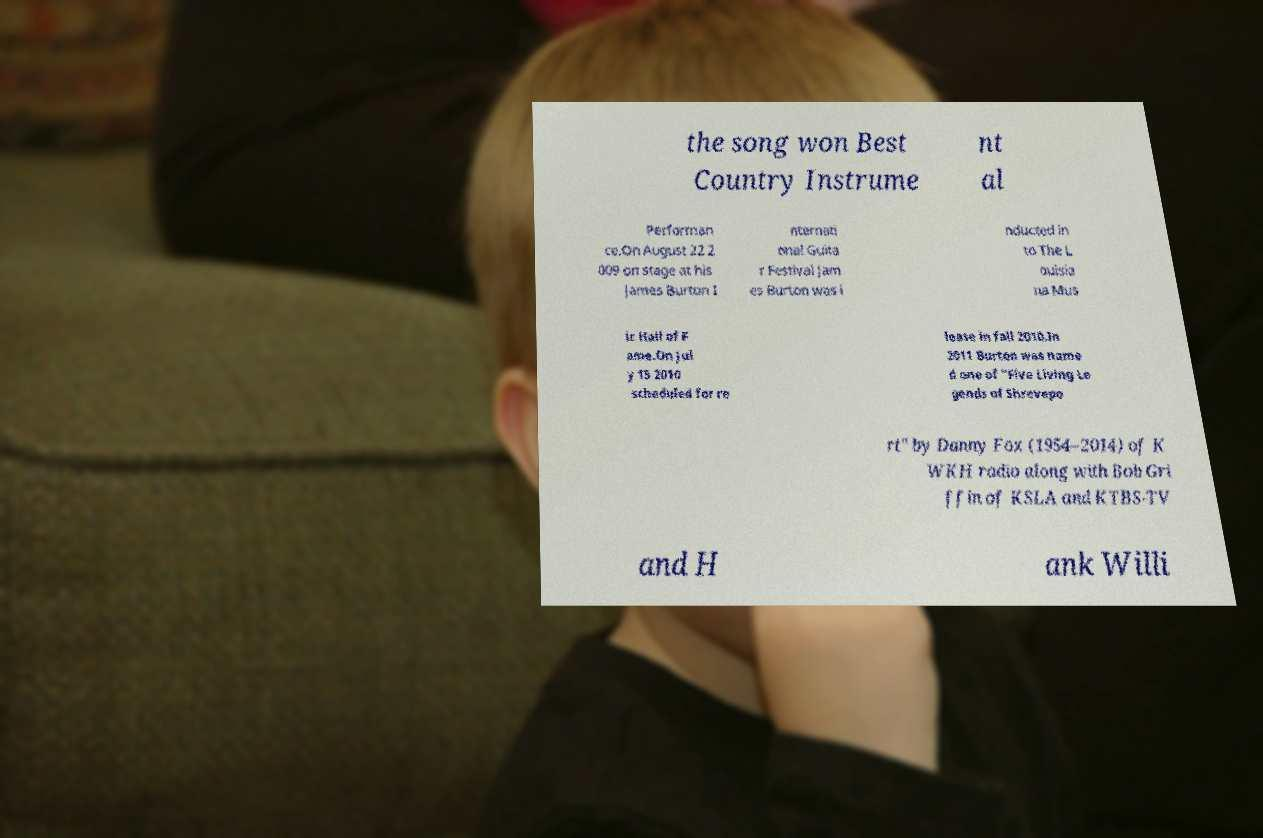Could you assist in decoding the text presented in this image and type it out clearly? the song won Best Country Instrume nt al Performan ce.On August 22 2 009 on stage at his James Burton I nternati onal Guita r Festival Jam es Burton was i nducted in to The L ouisia na Mus ic Hall of F ame.On Jul y 15 2010 scheduled for re lease in fall 2010.In 2011 Burton was name d one of "Five Living Le gends of Shrevepo rt" by Danny Fox (1954–2014) of K WKH radio along with Bob Gri ffin of KSLA and KTBS-TV and H ank Willi 